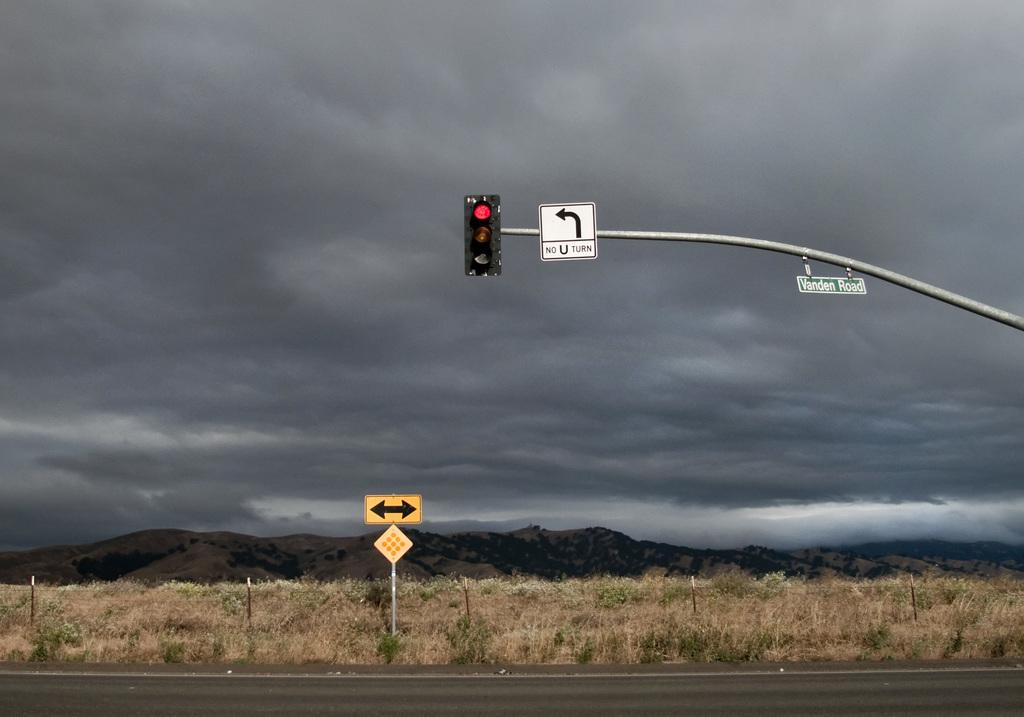<image>
Present a compact description of the photo's key features. A red stoplight next to a No U Turn sign. 